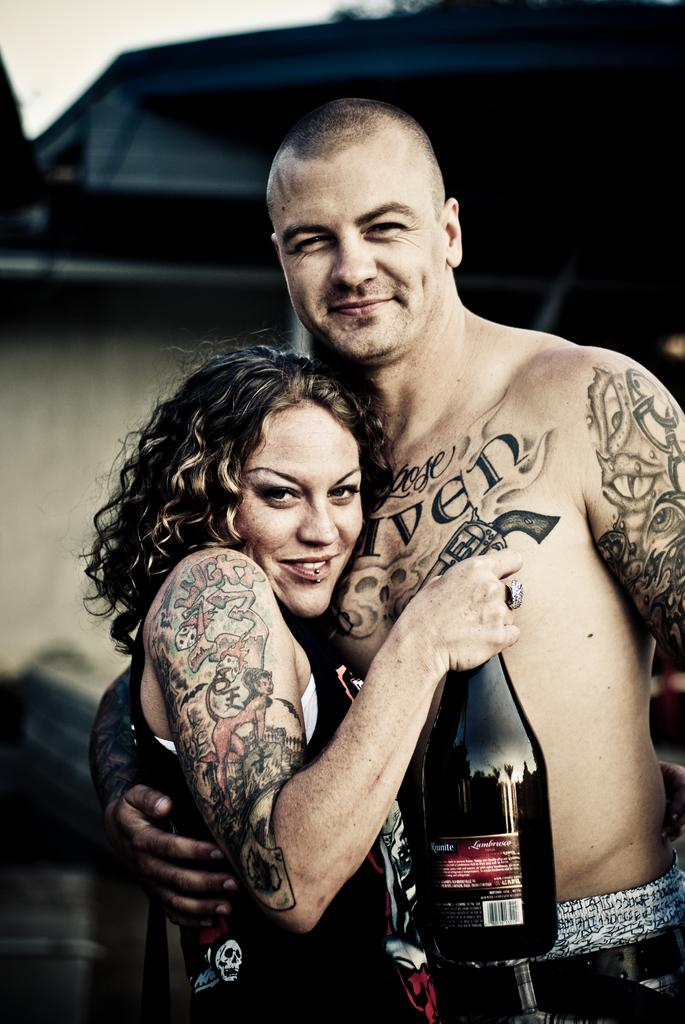How many people are in the image? There are two persons in the image. Where are the persons located in the image? The persons are standing in the middle of the image. What is the person on the left side holding? The person on the left side is holding a wine bottle. What can be seen in the background of the image? There is a wall in the background of the image. What type of seed can be seen sprouting from the ground in the image? There is no seed or sprouting plant visible in the image; it features two people standing and a wall in the background. 